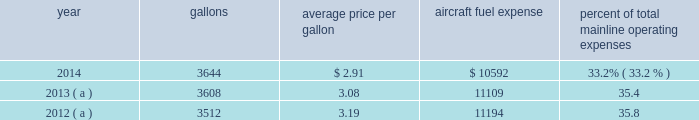Table of contents respect to the mainline american and the mainline us airways dispatchers , flight simulator engineers and flight crew training instructors , all of whom are now represented by the twu , a rival organization , the national association of airline professionals ( naap ) , filed single carrier applications seeking to represent those employees .
The nmb will have to determine that a single transportation system exists and will certify a post-merger representative of the combined employee groups before the process for negotiating new jcbas can begin .
The merger had no impact on the cbas that cover the employees of our wholly-owned subsidiary airlines which are not being merged ( envoy , piedmont and psa ) .
For those employees , the rla provides that cbas do not expire , but instead become amendable as of a stated date .
In 2014 , envoy pilots ratified a new 10 year collective bargaining agreement , piedmont pilots ratified a new 10 year collective bargaining agreement and piedmont flight attendants ratified a new five-year collective bargaining agreement .
With the exception of the passenger service employees who are now engaged in traditional rla negotiations that are expected to result in a jcba and the us airways flight simulator engineers and flight crew training instructors , other union-represented american mainline employees are covered by agreements that are not currently amendable .
Until those agreements become amendable , negotiations for jcbas will be conducted outside the traditional rla bargaining process described above , and , in the meantime , no self-help will be permissible .
The piedmont mechanics and stock clerks and the psa and piedmont dispatchers also have agreements that are now amendable and are engaged in traditional rla negotiations .
None of the unions representing our employees presently may lawfully engage in concerted refusals to work , such as strikes , slow-downs , sick-outs or other similar activity , against us .
Nonetheless , there is a risk that disgruntled employees , either with or without union involvement , could engage in one or more concerted refusals to work that could individually or collectively harm the operation of our airline and impair our financial performance .
For more discussion , see part i , item 1a .
Risk factors 2013 201cunion disputes , employee strikes and other labor-related disruptions may adversely affect our operations . 201d aircraft fuel our operations and financial results are significantly affected by the availability and price of jet fuel .
Based on our 2015 forecasted mainline and regional fuel consumption , we estimate that , as of december 31 , 2014 , a one cent per gallon increase in aviation fuel price would increase our 2015 annual fuel expense by $ 43 million .
The table shows annual aircraft fuel consumption and costs , including taxes , for our mainline operations for 2012 through 2014 ( gallons and aircraft fuel expense in millions ) .
Year gallons average price per gallon aircraft fuel expense percent of total mainline operating expenses .
( a ) represents 201ccombined 201d financial data , which includes the financial results of american and us airways group each on a standalone basis .
Total combined fuel expenses for our wholly-owned and third-party regional carriers operating under capacity purchase agreements of american and us airways group , each on a standalone basis , were $ 2.0 billion , $ 2.1 billion and $ 2.1 billion for the years ended december 31 , 2014 , 2013 and 2012 , respectively. .
What were total mainline operating expenses in 2014? 
Computations: (10592 / 33.2%)
Answer: 31903.61446. 